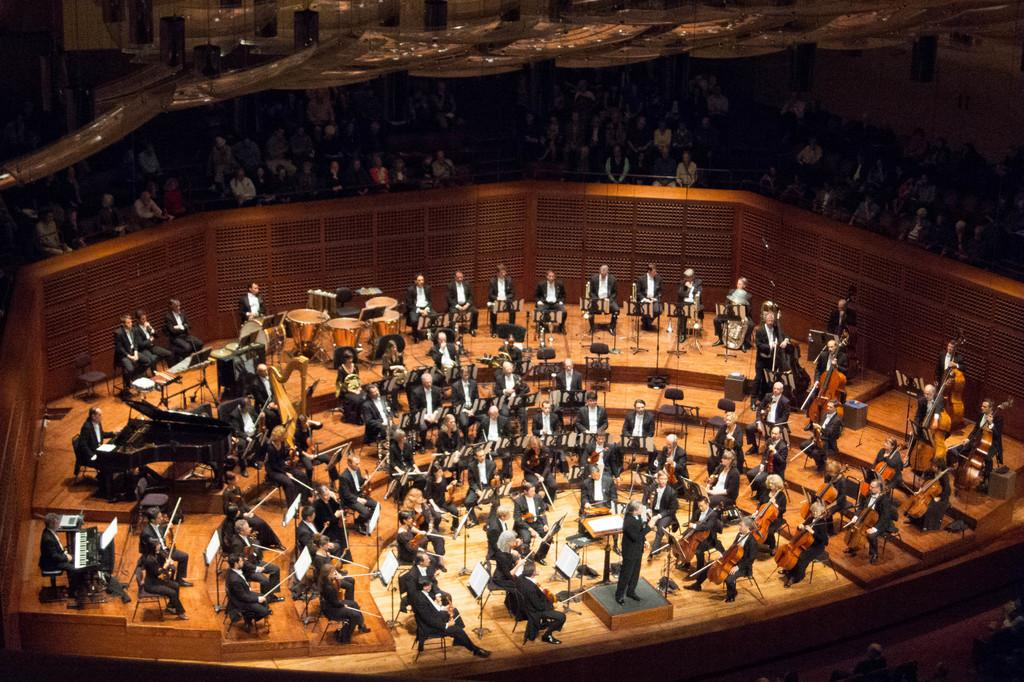What are the people in the image doing? There are people sitting and playing musical instruments in the image. What might be used to hold books or sheet music in the image? There are book stands in the image. Who is watching the people playing musical instruments? There is an audience visible in the image. How many clocks can be seen on the wall in the image? There is no mention of clocks or a wall in the image, so it is not possible to answer that question. 